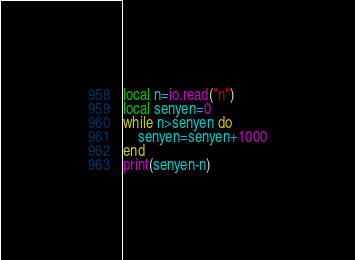<code> <loc_0><loc_0><loc_500><loc_500><_Lua_>local n=io.read("n")
local senyen=0
while n>senyen do
    senyen=senyen+1000
end
print(senyen-n)</code> 